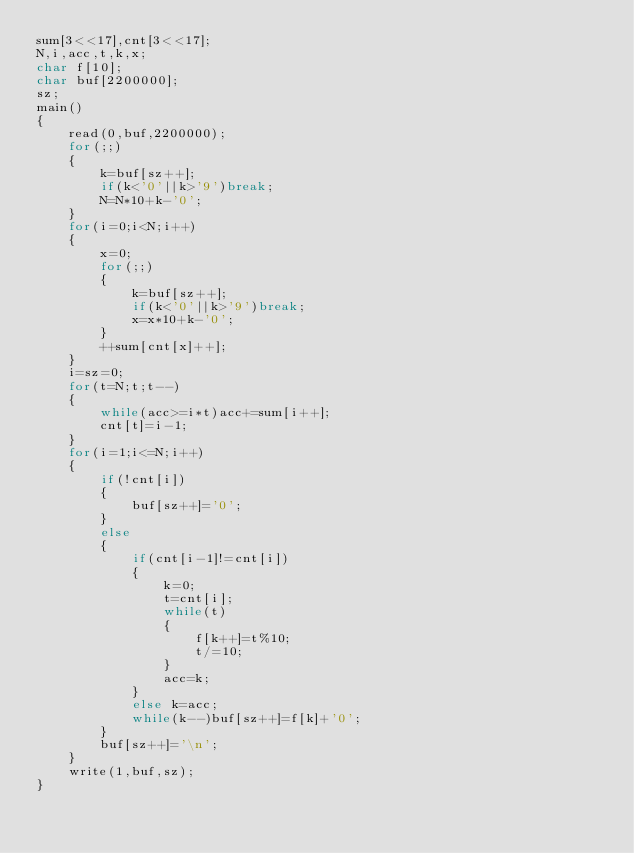<code> <loc_0><loc_0><loc_500><loc_500><_C_>sum[3<<17],cnt[3<<17];
N,i,acc,t,k,x;
char f[10];
char buf[2200000];
sz;
main()
{
	read(0,buf,2200000);
	for(;;)
	{
		k=buf[sz++];
		if(k<'0'||k>'9')break;
		N=N*10+k-'0';
	}
	for(i=0;i<N;i++)
	{
		x=0;
		for(;;)
		{
			k=buf[sz++];
			if(k<'0'||k>'9')break;
			x=x*10+k-'0';
		}
		++sum[cnt[x]++];
	}
	i=sz=0;
	for(t=N;t;t--)
	{
		while(acc>=i*t)acc+=sum[i++];
		cnt[t]=i-1;
	}
	for(i=1;i<=N;i++)
	{
		if(!cnt[i])
		{
			buf[sz++]='0';
		}
		else
		{
			if(cnt[i-1]!=cnt[i])
			{
				k=0;
				t=cnt[i];
				while(t)
				{
					f[k++]=t%10;
					t/=10;
				}
				acc=k;
			}
			else k=acc;
			while(k--)buf[sz++]=f[k]+'0';
		}
		buf[sz++]='\n';
	}
	write(1,buf,sz);
}</code> 